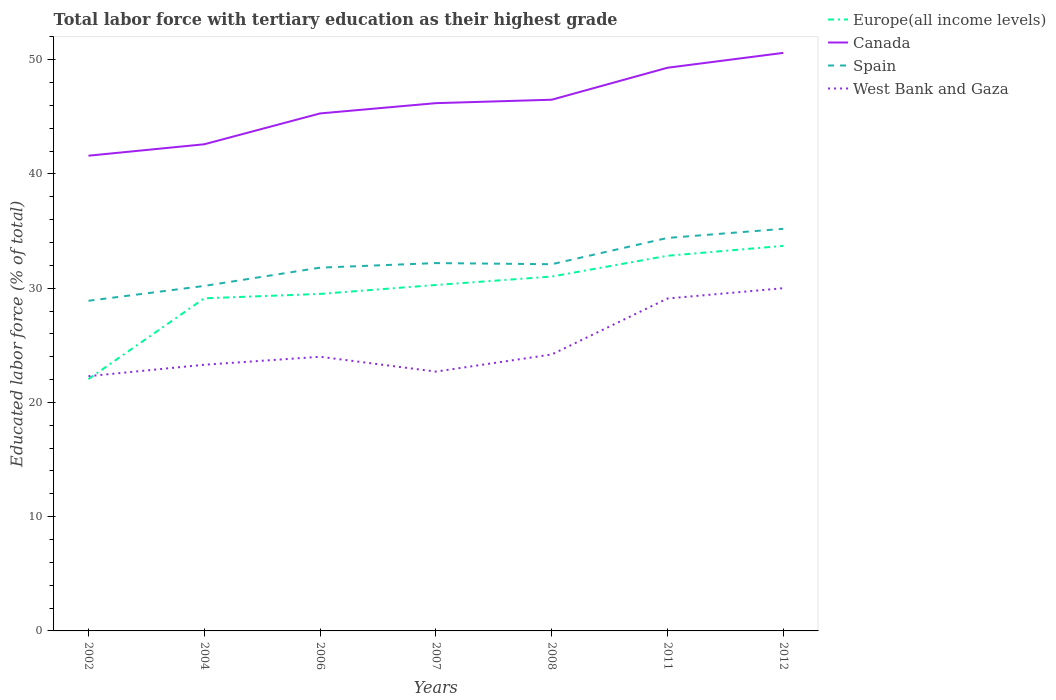Across all years, what is the maximum percentage of male labor force with tertiary education in West Bank and Gaza?
Your answer should be very brief. 22.3. In which year was the percentage of male labor force with tertiary education in West Bank and Gaza maximum?
Provide a succinct answer. 2002. What is the total percentage of male labor force with tertiary education in Spain in the graph?
Provide a short and direct response. -3.3. What is the difference between the highest and the second highest percentage of male labor force with tertiary education in Spain?
Your response must be concise. 6.3. What is the difference between the highest and the lowest percentage of male labor force with tertiary education in Europe(all income levels)?
Give a very brief answer. 4. How many lines are there?
Offer a terse response. 4. How many years are there in the graph?
Ensure brevity in your answer.  7. What is the difference between two consecutive major ticks on the Y-axis?
Offer a very short reply. 10. Does the graph contain any zero values?
Offer a terse response. No. Where does the legend appear in the graph?
Offer a terse response. Top right. How many legend labels are there?
Your answer should be very brief. 4. What is the title of the graph?
Keep it short and to the point. Total labor force with tertiary education as their highest grade. Does "Guatemala" appear as one of the legend labels in the graph?
Offer a terse response. No. What is the label or title of the X-axis?
Your response must be concise. Years. What is the label or title of the Y-axis?
Give a very brief answer. Educated labor force (% of total). What is the Educated labor force (% of total) of Europe(all income levels) in 2002?
Provide a succinct answer. 22.04. What is the Educated labor force (% of total) of Canada in 2002?
Ensure brevity in your answer.  41.6. What is the Educated labor force (% of total) in Spain in 2002?
Give a very brief answer. 28.9. What is the Educated labor force (% of total) in West Bank and Gaza in 2002?
Offer a very short reply. 22.3. What is the Educated labor force (% of total) of Europe(all income levels) in 2004?
Provide a succinct answer. 29.12. What is the Educated labor force (% of total) of Canada in 2004?
Provide a succinct answer. 42.6. What is the Educated labor force (% of total) in Spain in 2004?
Keep it short and to the point. 30.2. What is the Educated labor force (% of total) in West Bank and Gaza in 2004?
Provide a short and direct response. 23.3. What is the Educated labor force (% of total) in Europe(all income levels) in 2006?
Give a very brief answer. 29.5. What is the Educated labor force (% of total) in Canada in 2006?
Provide a succinct answer. 45.3. What is the Educated labor force (% of total) in Spain in 2006?
Offer a very short reply. 31.8. What is the Educated labor force (% of total) in Europe(all income levels) in 2007?
Your answer should be compact. 30.28. What is the Educated labor force (% of total) of Canada in 2007?
Make the answer very short. 46.2. What is the Educated labor force (% of total) in Spain in 2007?
Your answer should be compact. 32.2. What is the Educated labor force (% of total) in West Bank and Gaza in 2007?
Provide a short and direct response. 22.7. What is the Educated labor force (% of total) in Europe(all income levels) in 2008?
Provide a short and direct response. 31.02. What is the Educated labor force (% of total) of Canada in 2008?
Make the answer very short. 46.5. What is the Educated labor force (% of total) of Spain in 2008?
Offer a terse response. 32.1. What is the Educated labor force (% of total) in West Bank and Gaza in 2008?
Provide a short and direct response. 24.2. What is the Educated labor force (% of total) in Europe(all income levels) in 2011?
Offer a terse response. 32.84. What is the Educated labor force (% of total) of Canada in 2011?
Your answer should be compact. 49.3. What is the Educated labor force (% of total) in Spain in 2011?
Keep it short and to the point. 34.4. What is the Educated labor force (% of total) of West Bank and Gaza in 2011?
Give a very brief answer. 29.1. What is the Educated labor force (% of total) in Europe(all income levels) in 2012?
Your answer should be very brief. 33.71. What is the Educated labor force (% of total) in Canada in 2012?
Keep it short and to the point. 50.6. What is the Educated labor force (% of total) in Spain in 2012?
Make the answer very short. 35.2. Across all years, what is the maximum Educated labor force (% of total) of Europe(all income levels)?
Your response must be concise. 33.71. Across all years, what is the maximum Educated labor force (% of total) of Canada?
Your answer should be compact. 50.6. Across all years, what is the maximum Educated labor force (% of total) of Spain?
Give a very brief answer. 35.2. Across all years, what is the minimum Educated labor force (% of total) of Europe(all income levels)?
Provide a short and direct response. 22.04. Across all years, what is the minimum Educated labor force (% of total) of Canada?
Your answer should be very brief. 41.6. Across all years, what is the minimum Educated labor force (% of total) of Spain?
Provide a succinct answer. 28.9. Across all years, what is the minimum Educated labor force (% of total) of West Bank and Gaza?
Give a very brief answer. 22.3. What is the total Educated labor force (% of total) in Europe(all income levels) in the graph?
Make the answer very short. 208.51. What is the total Educated labor force (% of total) in Canada in the graph?
Provide a succinct answer. 322.1. What is the total Educated labor force (% of total) of Spain in the graph?
Make the answer very short. 224.8. What is the total Educated labor force (% of total) in West Bank and Gaza in the graph?
Your answer should be very brief. 175.6. What is the difference between the Educated labor force (% of total) of Europe(all income levels) in 2002 and that in 2004?
Provide a short and direct response. -7.07. What is the difference between the Educated labor force (% of total) of Canada in 2002 and that in 2004?
Make the answer very short. -1. What is the difference between the Educated labor force (% of total) in Europe(all income levels) in 2002 and that in 2006?
Your answer should be very brief. -7.46. What is the difference between the Educated labor force (% of total) in Spain in 2002 and that in 2006?
Give a very brief answer. -2.9. What is the difference between the Educated labor force (% of total) in West Bank and Gaza in 2002 and that in 2006?
Offer a terse response. -1.7. What is the difference between the Educated labor force (% of total) in Europe(all income levels) in 2002 and that in 2007?
Make the answer very short. -8.24. What is the difference between the Educated labor force (% of total) of Canada in 2002 and that in 2007?
Offer a terse response. -4.6. What is the difference between the Educated labor force (% of total) of Spain in 2002 and that in 2007?
Your answer should be very brief. -3.3. What is the difference between the Educated labor force (% of total) of Europe(all income levels) in 2002 and that in 2008?
Make the answer very short. -8.98. What is the difference between the Educated labor force (% of total) in Canada in 2002 and that in 2008?
Give a very brief answer. -4.9. What is the difference between the Educated labor force (% of total) in Europe(all income levels) in 2002 and that in 2011?
Ensure brevity in your answer.  -10.8. What is the difference between the Educated labor force (% of total) in Canada in 2002 and that in 2011?
Your answer should be very brief. -7.7. What is the difference between the Educated labor force (% of total) of West Bank and Gaza in 2002 and that in 2011?
Your answer should be compact. -6.8. What is the difference between the Educated labor force (% of total) in Europe(all income levels) in 2002 and that in 2012?
Provide a short and direct response. -11.66. What is the difference between the Educated labor force (% of total) in Spain in 2002 and that in 2012?
Your answer should be compact. -6.3. What is the difference between the Educated labor force (% of total) of Europe(all income levels) in 2004 and that in 2006?
Keep it short and to the point. -0.38. What is the difference between the Educated labor force (% of total) in Canada in 2004 and that in 2006?
Provide a short and direct response. -2.7. What is the difference between the Educated labor force (% of total) in Spain in 2004 and that in 2006?
Give a very brief answer. -1.6. What is the difference between the Educated labor force (% of total) of Europe(all income levels) in 2004 and that in 2007?
Ensure brevity in your answer.  -1.17. What is the difference between the Educated labor force (% of total) of Europe(all income levels) in 2004 and that in 2008?
Your answer should be very brief. -1.9. What is the difference between the Educated labor force (% of total) of Canada in 2004 and that in 2008?
Provide a short and direct response. -3.9. What is the difference between the Educated labor force (% of total) in West Bank and Gaza in 2004 and that in 2008?
Offer a terse response. -0.9. What is the difference between the Educated labor force (% of total) in Europe(all income levels) in 2004 and that in 2011?
Make the answer very short. -3.72. What is the difference between the Educated labor force (% of total) in West Bank and Gaza in 2004 and that in 2011?
Give a very brief answer. -5.8. What is the difference between the Educated labor force (% of total) of Europe(all income levels) in 2004 and that in 2012?
Your answer should be very brief. -4.59. What is the difference between the Educated labor force (% of total) of Canada in 2004 and that in 2012?
Provide a succinct answer. -8. What is the difference between the Educated labor force (% of total) of Europe(all income levels) in 2006 and that in 2007?
Offer a very short reply. -0.78. What is the difference between the Educated labor force (% of total) in Spain in 2006 and that in 2007?
Provide a succinct answer. -0.4. What is the difference between the Educated labor force (% of total) in West Bank and Gaza in 2006 and that in 2007?
Your answer should be compact. 1.3. What is the difference between the Educated labor force (% of total) of Europe(all income levels) in 2006 and that in 2008?
Provide a succinct answer. -1.52. What is the difference between the Educated labor force (% of total) in Europe(all income levels) in 2006 and that in 2011?
Your response must be concise. -3.34. What is the difference between the Educated labor force (% of total) in Canada in 2006 and that in 2011?
Offer a very short reply. -4. What is the difference between the Educated labor force (% of total) in Spain in 2006 and that in 2011?
Provide a succinct answer. -2.6. What is the difference between the Educated labor force (% of total) in Europe(all income levels) in 2006 and that in 2012?
Your response must be concise. -4.21. What is the difference between the Educated labor force (% of total) of Canada in 2006 and that in 2012?
Your answer should be compact. -5.3. What is the difference between the Educated labor force (% of total) in West Bank and Gaza in 2006 and that in 2012?
Give a very brief answer. -6. What is the difference between the Educated labor force (% of total) of Europe(all income levels) in 2007 and that in 2008?
Offer a terse response. -0.74. What is the difference between the Educated labor force (% of total) in Spain in 2007 and that in 2008?
Give a very brief answer. 0.1. What is the difference between the Educated labor force (% of total) of West Bank and Gaza in 2007 and that in 2008?
Provide a short and direct response. -1.5. What is the difference between the Educated labor force (% of total) of Europe(all income levels) in 2007 and that in 2011?
Give a very brief answer. -2.56. What is the difference between the Educated labor force (% of total) of Canada in 2007 and that in 2011?
Your response must be concise. -3.1. What is the difference between the Educated labor force (% of total) of Spain in 2007 and that in 2011?
Your response must be concise. -2.2. What is the difference between the Educated labor force (% of total) of Europe(all income levels) in 2007 and that in 2012?
Your response must be concise. -3.42. What is the difference between the Educated labor force (% of total) of Spain in 2007 and that in 2012?
Your answer should be very brief. -3. What is the difference between the Educated labor force (% of total) of Europe(all income levels) in 2008 and that in 2011?
Offer a very short reply. -1.82. What is the difference between the Educated labor force (% of total) of Spain in 2008 and that in 2011?
Ensure brevity in your answer.  -2.3. What is the difference between the Educated labor force (% of total) of West Bank and Gaza in 2008 and that in 2011?
Your response must be concise. -4.9. What is the difference between the Educated labor force (% of total) in Europe(all income levels) in 2008 and that in 2012?
Ensure brevity in your answer.  -2.69. What is the difference between the Educated labor force (% of total) in Canada in 2008 and that in 2012?
Keep it short and to the point. -4.1. What is the difference between the Educated labor force (% of total) of West Bank and Gaza in 2008 and that in 2012?
Ensure brevity in your answer.  -5.8. What is the difference between the Educated labor force (% of total) of Europe(all income levels) in 2011 and that in 2012?
Your answer should be compact. -0.87. What is the difference between the Educated labor force (% of total) of Spain in 2011 and that in 2012?
Ensure brevity in your answer.  -0.8. What is the difference between the Educated labor force (% of total) in West Bank and Gaza in 2011 and that in 2012?
Ensure brevity in your answer.  -0.9. What is the difference between the Educated labor force (% of total) of Europe(all income levels) in 2002 and the Educated labor force (% of total) of Canada in 2004?
Provide a succinct answer. -20.56. What is the difference between the Educated labor force (% of total) of Europe(all income levels) in 2002 and the Educated labor force (% of total) of Spain in 2004?
Offer a very short reply. -8.16. What is the difference between the Educated labor force (% of total) in Europe(all income levels) in 2002 and the Educated labor force (% of total) in West Bank and Gaza in 2004?
Provide a short and direct response. -1.26. What is the difference between the Educated labor force (% of total) of Canada in 2002 and the Educated labor force (% of total) of Spain in 2004?
Ensure brevity in your answer.  11.4. What is the difference between the Educated labor force (% of total) of Canada in 2002 and the Educated labor force (% of total) of West Bank and Gaza in 2004?
Your answer should be compact. 18.3. What is the difference between the Educated labor force (% of total) of Spain in 2002 and the Educated labor force (% of total) of West Bank and Gaza in 2004?
Offer a very short reply. 5.6. What is the difference between the Educated labor force (% of total) in Europe(all income levels) in 2002 and the Educated labor force (% of total) in Canada in 2006?
Give a very brief answer. -23.26. What is the difference between the Educated labor force (% of total) in Europe(all income levels) in 2002 and the Educated labor force (% of total) in Spain in 2006?
Ensure brevity in your answer.  -9.76. What is the difference between the Educated labor force (% of total) of Europe(all income levels) in 2002 and the Educated labor force (% of total) of West Bank and Gaza in 2006?
Provide a succinct answer. -1.96. What is the difference between the Educated labor force (% of total) of Canada in 2002 and the Educated labor force (% of total) of Spain in 2006?
Provide a short and direct response. 9.8. What is the difference between the Educated labor force (% of total) of Europe(all income levels) in 2002 and the Educated labor force (% of total) of Canada in 2007?
Provide a short and direct response. -24.16. What is the difference between the Educated labor force (% of total) in Europe(all income levels) in 2002 and the Educated labor force (% of total) in Spain in 2007?
Offer a very short reply. -10.16. What is the difference between the Educated labor force (% of total) of Europe(all income levels) in 2002 and the Educated labor force (% of total) of West Bank and Gaza in 2007?
Provide a succinct answer. -0.66. What is the difference between the Educated labor force (% of total) in Canada in 2002 and the Educated labor force (% of total) in West Bank and Gaza in 2007?
Offer a very short reply. 18.9. What is the difference between the Educated labor force (% of total) in Spain in 2002 and the Educated labor force (% of total) in West Bank and Gaza in 2007?
Provide a short and direct response. 6.2. What is the difference between the Educated labor force (% of total) of Europe(all income levels) in 2002 and the Educated labor force (% of total) of Canada in 2008?
Provide a short and direct response. -24.46. What is the difference between the Educated labor force (% of total) in Europe(all income levels) in 2002 and the Educated labor force (% of total) in Spain in 2008?
Keep it short and to the point. -10.06. What is the difference between the Educated labor force (% of total) of Europe(all income levels) in 2002 and the Educated labor force (% of total) of West Bank and Gaza in 2008?
Your answer should be compact. -2.16. What is the difference between the Educated labor force (% of total) of Canada in 2002 and the Educated labor force (% of total) of Spain in 2008?
Your answer should be very brief. 9.5. What is the difference between the Educated labor force (% of total) in Europe(all income levels) in 2002 and the Educated labor force (% of total) in Canada in 2011?
Keep it short and to the point. -27.26. What is the difference between the Educated labor force (% of total) in Europe(all income levels) in 2002 and the Educated labor force (% of total) in Spain in 2011?
Your answer should be compact. -12.36. What is the difference between the Educated labor force (% of total) in Europe(all income levels) in 2002 and the Educated labor force (% of total) in West Bank and Gaza in 2011?
Provide a short and direct response. -7.06. What is the difference between the Educated labor force (% of total) of Canada in 2002 and the Educated labor force (% of total) of Spain in 2011?
Provide a short and direct response. 7.2. What is the difference between the Educated labor force (% of total) in Canada in 2002 and the Educated labor force (% of total) in West Bank and Gaza in 2011?
Offer a very short reply. 12.5. What is the difference between the Educated labor force (% of total) of Spain in 2002 and the Educated labor force (% of total) of West Bank and Gaza in 2011?
Offer a terse response. -0.2. What is the difference between the Educated labor force (% of total) of Europe(all income levels) in 2002 and the Educated labor force (% of total) of Canada in 2012?
Give a very brief answer. -28.56. What is the difference between the Educated labor force (% of total) of Europe(all income levels) in 2002 and the Educated labor force (% of total) of Spain in 2012?
Give a very brief answer. -13.16. What is the difference between the Educated labor force (% of total) of Europe(all income levels) in 2002 and the Educated labor force (% of total) of West Bank and Gaza in 2012?
Give a very brief answer. -7.96. What is the difference between the Educated labor force (% of total) in Canada in 2002 and the Educated labor force (% of total) in West Bank and Gaza in 2012?
Give a very brief answer. 11.6. What is the difference between the Educated labor force (% of total) in Spain in 2002 and the Educated labor force (% of total) in West Bank and Gaza in 2012?
Give a very brief answer. -1.1. What is the difference between the Educated labor force (% of total) of Europe(all income levels) in 2004 and the Educated labor force (% of total) of Canada in 2006?
Your answer should be compact. -16.18. What is the difference between the Educated labor force (% of total) in Europe(all income levels) in 2004 and the Educated labor force (% of total) in Spain in 2006?
Your answer should be compact. -2.68. What is the difference between the Educated labor force (% of total) of Europe(all income levels) in 2004 and the Educated labor force (% of total) of West Bank and Gaza in 2006?
Your answer should be very brief. 5.12. What is the difference between the Educated labor force (% of total) of Canada in 2004 and the Educated labor force (% of total) of Spain in 2006?
Your response must be concise. 10.8. What is the difference between the Educated labor force (% of total) in Canada in 2004 and the Educated labor force (% of total) in West Bank and Gaza in 2006?
Provide a succinct answer. 18.6. What is the difference between the Educated labor force (% of total) in Europe(all income levels) in 2004 and the Educated labor force (% of total) in Canada in 2007?
Ensure brevity in your answer.  -17.08. What is the difference between the Educated labor force (% of total) of Europe(all income levels) in 2004 and the Educated labor force (% of total) of Spain in 2007?
Make the answer very short. -3.08. What is the difference between the Educated labor force (% of total) of Europe(all income levels) in 2004 and the Educated labor force (% of total) of West Bank and Gaza in 2007?
Keep it short and to the point. 6.42. What is the difference between the Educated labor force (% of total) of Canada in 2004 and the Educated labor force (% of total) of Spain in 2007?
Provide a short and direct response. 10.4. What is the difference between the Educated labor force (% of total) in Spain in 2004 and the Educated labor force (% of total) in West Bank and Gaza in 2007?
Your response must be concise. 7.5. What is the difference between the Educated labor force (% of total) in Europe(all income levels) in 2004 and the Educated labor force (% of total) in Canada in 2008?
Offer a terse response. -17.38. What is the difference between the Educated labor force (% of total) in Europe(all income levels) in 2004 and the Educated labor force (% of total) in Spain in 2008?
Keep it short and to the point. -2.98. What is the difference between the Educated labor force (% of total) in Europe(all income levels) in 2004 and the Educated labor force (% of total) in West Bank and Gaza in 2008?
Your response must be concise. 4.92. What is the difference between the Educated labor force (% of total) of Canada in 2004 and the Educated labor force (% of total) of Spain in 2008?
Your response must be concise. 10.5. What is the difference between the Educated labor force (% of total) in Canada in 2004 and the Educated labor force (% of total) in West Bank and Gaza in 2008?
Your answer should be compact. 18.4. What is the difference between the Educated labor force (% of total) in Spain in 2004 and the Educated labor force (% of total) in West Bank and Gaza in 2008?
Provide a short and direct response. 6. What is the difference between the Educated labor force (% of total) of Europe(all income levels) in 2004 and the Educated labor force (% of total) of Canada in 2011?
Ensure brevity in your answer.  -20.18. What is the difference between the Educated labor force (% of total) of Europe(all income levels) in 2004 and the Educated labor force (% of total) of Spain in 2011?
Your answer should be compact. -5.28. What is the difference between the Educated labor force (% of total) in Europe(all income levels) in 2004 and the Educated labor force (% of total) in West Bank and Gaza in 2011?
Make the answer very short. 0.02. What is the difference between the Educated labor force (% of total) in Canada in 2004 and the Educated labor force (% of total) in West Bank and Gaza in 2011?
Provide a short and direct response. 13.5. What is the difference between the Educated labor force (% of total) of Europe(all income levels) in 2004 and the Educated labor force (% of total) of Canada in 2012?
Provide a short and direct response. -21.48. What is the difference between the Educated labor force (% of total) in Europe(all income levels) in 2004 and the Educated labor force (% of total) in Spain in 2012?
Make the answer very short. -6.08. What is the difference between the Educated labor force (% of total) in Europe(all income levels) in 2004 and the Educated labor force (% of total) in West Bank and Gaza in 2012?
Ensure brevity in your answer.  -0.88. What is the difference between the Educated labor force (% of total) of Canada in 2004 and the Educated labor force (% of total) of West Bank and Gaza in 2012?
Offer a terse response. 12.6. What is the difference between the Educated labor force (% of total) of Europe(all income levels) in 2006 and the Educated labor force (% of total) of Canada in 2007?
Offer a terse response. -16.7. What is the difference between the Educated labor force (% of total) in Europe(all income levels) in 2006 and the Educated labor force (% of total) in Spain in 2007?
Provide a succinct answer. -2.7. What is the difference between the Educated labor force (% of total) in Europe(all income levels) in 2006 and the Educated labor force (% of total) in West Bank and Gaza in 2007?
Your answer should be compact. 6.8. What is the difference between the Educated labor force (% of total) in Canada in 2006 and the Educated labor force (% of total) in Spain in 2007?
Offer a terse response. 13.1. What is the difference between the Educated labor force (% of total) in Canada in 2006 and the Educated labor force (% of total) in West Bank and Gaza in 2007?
Give a very brief answer. 22.6. What is the difference between the Educated labor force (% of total) in Spain in 2006 and the Educated labor force (% of total) in West Bank and Gaza in 2007?
Your response must be concise. 9.1. What is the difference between the Educated labor force (% of total) in Europe(all income levels) in 2006 and the Educated labor force (% of total) in Canada in 2008?
Your answer should be very brief. -17. What is the difference between the Educated labor force (% of total) of Europe(all income levels) in 2006 and the Educated labor force (% of total) of Spain in 2008?
Offer a very short reply. -2.6. What is the difference between the Educated labor force (% of total) of Europe(all income levels) in 2006 and the Educated labor force (% of total) of West Bank and Gaza in 2008?
Make the answer very short. 5.3. What is the difference between the Educated labor force (% of total) in Canada in 2006 and the Educated labor force (% of total) in Spain in 2008?
Your answer should be very brief. 13.2. What is the difference between the Educated labor force (% of total) in Canada in 2006 and the Educated labor force (% of total) in West Bank and Gaza in 2008?
Keep it short and to the point. 21.1. What is the difference between the Educated labor force (% of total) in Spain in 2006 and the Educated labor force (% of total) in West Bank and Gaza in 2008?
Provide a short and direct response. 7.6. What is the difference between the Educated labor force (% of total) of Europe(all income levels) in 2006 and the Educated labor force (% of total) of Canada in 2011?
Your answer should be very brief. -19.8. What is the difference between the Educated labor force (% of total) of Europe(all income levels) in 2006 and the Educated labor force (% of total) of Spain in 2011?
Offer a very short reply. -4.9. What is the difference between the Educated labor force (% of total) of Europe(all income levels) in 2006 and the Educated labor force (% of total) of West Bank and Gaza in 2011?
Your answer should be very brief. 0.4. What is the difference between the Educated labor force (% of total) of Canada in 2006 and the Educated labor force (% of total) of Spain in 2011?
Make the answer very short. 10.9. What is the difference between the Educated labor force (% of total) of Canada in 2006 and the Educated labor force (% of total) of West Bank and Gaza in 2011?
Give a very brief answer. 16.2. What is the difference between the Educated labor force (% of total) of Europe(all income levels) in 2006 and the Educated labor force (% of total) of Canada in 2012?
Provide a short and direct response. -21.1. What is the difference between the Educated labor force (% of total) in Europe(all income levels) in 2006 and the Educated labor force (% of total) in Spain in 2012?
Ensure brevity in your answer.  -5.7. What is the difference between the Educated labor force (% of total) of Europe(all income levels) in 2006 and the Educated labor force (% of total) of West Bank and Gaza in 2012?
Provide a succinct answer. -0.5. What is the difference between the Educated labor force (% of total) in Canada in 2006 and the Educated labor force (% of total) in West Bank and Gaza in 2012?
Offer a terse response. 15.3. What is the difference between the Educated labor force (% of total) of Spain in 2006 and the Educated labor force (% of total) of West Bank and Gaza in 2012?
Your response must be concise. 1.8. What is the difference between the Educated labor force (% of total) in Europe(all income levels) in 2007 and the Educated labor force (% of total) in Canada in 2008?
Provide a succinct answer. -16.22. What is the difference between the Educated labor force (% of total) in Europe(all income levels) in 2007 and the Educated labor force (% of total) in Spain in 2008?
Provide a succinct answer. -1.82. What is the difference between the Educated labor force (% of total) in Europe(all income levels) in 2007 and the Educated labor force (% of total) in West Bank and Gaza in 2008?
Keep it short and to the point. 6.08. What is the difference between the Educated labor force (% of total) of Europe(all income levels) in 2007 and the Educated labor force (% of total) of Canada in 2011?
Provide a succinct answer. -19.02. What is the difference between the Educated labor force (% of total) of Europe(all income levels) in 2007 and the Educated labor force (% of total) of Spain in 2011?
Offer a terse response. -4.12. What is the difference between the Educated labor force (% of total) of Europe(all income levels) in 2007 and the Educated labor force (% of total) of West Bank and Gaza in 2011?
Your response must be concise. 1.18. What is the difference between the Educated labor force (% of total) in Canada in 2007 and the Educated labor force (% of total) in Spain in 2011?
Provide a succinct answer. 11.8. What is the difference between the Educated labor force (% of total) of Spain in 2007 and the Educated labor force (% of total) of West Bank and Gaza in 2011?
Provide a succinct answer. 3.1. What is the difference between the Educated labor force (% of total) in Europe(all income levels) in 2007 and the Educated labor force (% of total) in Canada in 2012?
Offer a very short reply. -20.32. What is the difference between the Educated labor force (% of total) of Europe(all income levels) in 2007 and the Educated labor force (% of total) of Spain in 2012?
Your response must be concise. -4.92. What is the difference between the Educated labor force (% of total) of Europe(all income levels) in 2007 and the Educated labor force (% of total) of West Bank and Gaza in 2012?
Your answer should be compact. 0.28. What is the difference between the Educated labor force (% of total) of Canada in 2007 and the Educated labor force (% of total) of West Bank and Gaza in 2012?
Your answer should be very brief. 16.2. What is the difference between the Educated labor force (% of total) in Europe(all income levels) in 2008 and the Educated labor force (% of total) in Canada in 2011?
Keep it short and to the point. -18.28. What is the difference between the Educated labor force (% of total) in Europe(all income levels) in 2008 and the Educated labor force (% of total) in Spain in 2011?
Your answer should be compact. -3.38. What is the difference between the Educated labor force (% of total) of Europe(all income levels) in 2008 and the Educated labor force (% of total) of West Bank and Gaza in 2011?
Your answer should be very brief. 1.92. What is the difference between the Educated labor force (% of total) in Canada in 2008 and the Educated labor force (% of total) in West Bank and Gaza in 2011?
Your answer should be compact. 17.4. What is the difference between the Educated labor force (% of total) in Europe(all income levels) in 2008 and the Educated labor force (% of total) in Canada in 2012?
Your answer should be compact. -19.58. What is the difference between the Educated labor force (% of total) in Europe(all income levels) in 2008 and the Educated labor force (% of total) in Spain in 2012?
Provide a short and direct response. -4.18. What is the difference between the Educated labor force (% of total) in Europe(all income levels) in 2008 and the Educated labor force (% of total) in West Bank and Gaza in 2012?
Provide a succinct answer. 1.02. What is the difference between the Educated labor force (% of total) of Canada in 2008 and the Educated labor force (% of total) of West Bank and Gaza in 2012?
Offer a terse response. 16.5. What is the difference between the Educated labor force (% of total) of Spain in 2008 and the Educated labor force (% of total) of West Bank and Gaza in 2012?
Offer a very short reply. 2.1. What is the difference between the Educated labor force (% of total) of Europe(all income levels) in 2011 and the Educated labor force (% of total) of Canada in 2012?
Give a very brief answer. -17.76. What is the difference between the Educated labor force (% of total) of Europe(all income levels) in 2011 and the Educated labor force (% of total) of Spain in 2012?
Your answer should be very brief. -2.36. What is the difference between the Educated labor force (% of total) of Europe(all income levels) in 2011 and the Educated labor force (% of total) of West Bank and Gaza in 2012?
Make the answer very short. 2.84. What is the difference between the Educated labor force (% of total) in Canada in 2011 and the Educated labor force (% of total) in Spain in 2012?
Ensure brevity in your answer.  14.1. What is the difference between the Educated labor force (% of total) in Canada in 2011 and the Educated labor force (% of total) in West Bank and Gaza in 2012?
Offer a very short reply. 19.3. What is the average Educated labor force (% of total) in Europe(all income levels) per year?
Keep it short and to the point. 29.79. What is the average Educated labor force (% of total) of Canada per year?
Offer a very short reply. 46.01. What is the average Educated labor force (% of total) of Spain per year?
Provide a succinct answer. 32.11. What is the average Educated labor force (% of total) in West Bank and Gaza per year?
Offer a terse response. 25.09. In the year 2002, what is the difference between the Educated labor force (% of total) in Europe(all income levels) and Educated labor force (% of total) in Canada?
Make the answer very short. -19.56. In the year 2002, what is the difference between the Educated labor force (% of total) of Europe(all income levels) and Educated labor force (% of total) of Spain?
Provide a succinct answer. -6.86. In the year 2002, what is the difference between the Educated labor force (% of total) in Europe(all income levels) and Educated labor force (% of total) in West Bank and Gaza?
Give a very brief answer. -0.26. In the year 2002, what is the difference between the Educated labor force (% of total) of Canada and Educated labor force (% of total) of Spain?
Your response must be concise. 12.7. In the year 2002, what is the difference between the Educated labor force (% of total) in Canada and Educated labor force (% of total) in West Bank and Gaza?
Ensure brevity in your answer.  19.3. In the year 2002, what is the difference between the Educated labor force (% of total) in Spain and Educated labor force (% of total) in West Bank and Gaza?
Your response must be concise. 6.6. In the year 2004, what is the difference between the Educated labor force (% of total) of Europe(all income levels) and Educated labor force (% of total) of Canada?
Provide a succinct answer. -13.48. In the year 2004, what is the difference between the Educated labor force (% of total) in Europe(all income levels) and Educated labor force (% of total) in Spain?
Provide a succinct answer. -1.08. In the year 2004, what is the difference between the Educated labor force (% of total) in Europe(all income levels) and Educated labor force (% of total) in West Bank and Gaza?
Offer a terse response. 5.82. In the year 2004, what is the difference between the Educated labor force (% of total) in Canada and Educated labor force (% of total) in Spain?
Provide a short and direct response. 12.4. In the year 2004, what is the difference between the Educated labor force (% of total) in Canada and Educated labor force (% of total) in West Bank and Gaza?
Ensure brevity in your answer.  19.3. In the year 2004, what is the difference between the Educated labor force (% of total) of Spain and Educated labor force (% of total) of West Bank and Gaza?
Ensure brevity in your answer.  6.9. In the year 2006, what is the difference between the Educated labor force (% of total) in Europe(all income levels) and Educated labor force (% of total) in Canada?
Your answer should be compact. -15.8. In the year 2006, what is the difference between the Educated labor force (% of total) of Europe(all income levels) and Educated labor force (% of total) of Spain?
Provide a short and direct response. -2.3. In the year 2006, what is the difference between the Educated labor force (% of total) in Europe(all income levels) and Educated labor force (% of total) in West Bank and Gaza?
Offer a very short reply. 5.5. In the year 2006, what is the difference between the Educated labor force (% of total) in Canada and Educated labor force (% of total) in West Bank and Gaza?
Your response must be concise. 21.3. In the year 2007, what is the difference between the Educated labor force (% of total) in Europe(all income levels) and Educated labor force (% of total) in Canada?
Offer a terse response. -15.92. In the year 2007, what is the difference between the Educated labor force (% of total) of Europe(all income levels) and Educated labor force (% of total) of Spain?
Provide a short and direct response. -1.92. In the year 2007, what is the difference between the Educated labor force (% of total) in Europe(all income levels) and Educated labor force (% of total) in West Bank and Gaza?
Your answer should be compact. 7.58. In the year 2007, what is the difference between the Educated labor force (% of total) of Canada and Educated labor force (% of total) of West Bank and Gaza?
Your answer should be compact. 23.5. In the year 2007, what is the difference between the Educated labor force (% of total) of Spain and Educated labor force (% of total) of West Bank and Gaza?
Your answer should be compact. 9.5. In the year 2008, what is the difference between the Educated labor force (% of total) in Europe(all income levels) and Educated labor force (% of total) in Canada?
Provide a succinct answer. -15.48. In the year 2008, what is the difference between the Educated labor force (% of total) in Europe(all income levels) and Educated labor force (% of total) in Spain?
Offer a very short reply. -1.08. In the year 2008, what is the difference between the Educated labor force (% of total) in Europe(all income levels) and Educated labor force (% of total) in West Bank and Gaza?
Your response must be concise. 6.82. In the year 2008, what is the difference between the Educated labor force (% of total) of Canada and Educated labor force (% of total) of West Bank and Gaza?
Your response must be concise. 22.3. In the year 2008, what is the difference between the Educated labor force (% of total) of Spain and Educated labor force (% of total) of West Bank and Gaza?
Provide a short and direct response. 7.9. In the year 2011, what is the difference between the Educated labor force (% of total) in Europe(all income levels) and Educated labor force (% of total) in Canada?
Make the answer very short. -16.46. In the year 2011, what is the difference between the Educated labor force (% of total) in Europe(all income levels) and Educated labor force (% of total) in Spain?
Offer a very short reply. -1.56. In the year 2011, what is the difference between the Educated labor force (% of total) of Europe(all income levels) and Educated labor force (% of total) of West Bank and Gaza?
Provide a short and direct response. 3.74. In the year 2011, what is the difference between the Educated labor force (% of total) of Canada and Educated labor force (% of total) of West Bank and Gaza?
Provide a succinct answer. 20.2. In the year 2011, what is the difference between the Educated labor force (% of total) of Spain and Educated labor force (% of total) of West Bank and Gaza?
Give a very brief answer. 5.3. In the year 2012, what is the difference between the Educated labor force (% of total) of Europe(all income levels) and Educated labor force (% of total) of Canada?
Provide a succinct answer. -16.89. In the year 2012, what is the difference between the Educated labor force (% of total) in Europe(all income levels) and Educated labor force (% of total) in Spain?
Keep it short and to the point. -1.49. In the year 2012, what is the difference between the Educated labor force (% of total) of Europe(all income levels) and Educated labor force (% of total) of West Bank and Gaza?
Keep it short and to the point. 3.71. In the year 2012, what is the difference between the Educated labor force (% of total) in Canada and Educated labor force (% of total) in Spain?
Your answer should be very brief. 15.4. In the year 2012, what is the difference between the Educated labor force (% of total) in Canada and Educated labor force (% of total) in West Bank and Gaza?
Ensure brevity in your answer.  20.6. What is the ratio of the Educated labor force (% of total) of Europe(all income levels) in 2002 to that in 2004?
Give a very brief answer. 0.76. What is the ratio of the Educated labor force (% of total) of Canada in 2002 to that in 2004?
Make the answer very short. 0.98. What is the ratio of the Educated labor force (% of total) of Spain in 2002 to that in 2004?
Your response must be concise. 0.96. What is the ratio of the Educated labor force (% of total) of West Bank and Gaza in 2002 to that in 2004?
Provide a short and direct response. 0.96. What is the ratio of the Educated labor force (% of total) of Europe(all income levels) in 2002 to that in 2006?
Offer a very short reply. 0.75. What is the ratio of the Educated labor force (% of total) of Canada in 2002 to that in 2006?
Keep it short and to the point. 0.92. What is the ratio of the Educated labor force (% of total) of Spain in 2002 to that in 2006?
Offer a very short reply. 0.91. What is the ratio of the Educated labor force (% of total) of West Bank and Gaza in 2002 to that in 2006?
Your response must be concise. 0.93. What is the ratio of the Educated labor force (% of total) in Europe(all income levels) in 2002 to that in 2007?
Provide a succinct answer. 0.73. What is the ratio of the Educated labor force (% of total) in Canada in 2002 to that in 2007?
Give a very brief answer. 0.9. What is the ratio of the Educated labor force (% of total) of Spain in 2002 to that in 2007?
Offer a terse response. 0.9. What is the ratio of the Educated labor force (% of total) in West Bank and Gaza in 2002 to that in 2007?
Offer a terse response. 0.98. What is the ratio of the Educated labor force (% of total) of Europe(all income levels) in 2002 to that in 2008?
Keep it short and to the point. 0.71. What is the ratio of the Educated labor force (% of total) of Canada in 2002 to that in 2008?
Your answer should be compact. 0.89. What is the ratio of the Educated labor force (% of total) of Spain in 2002 to that in 2008?
Ensure brevity in your answer.  0.9. What is the ratio of the Educated labor force (% of total) of West Bank and Gaza in 2002 to that in 2008?
Give a very brief answer. 0.92. What is the ratio of the Educated labor force (% of total) of Europe(all income levels) in 2002 to that in 2011?
Provide a short and direct response. 0.67. What is the ratio of the Educated labor force (% of total) of Canada in 2002 to that in 2011?
Your response must be concise. 0.84. What is the ratio of the Educated labor force (% of total) in Spain in 2002 to that in 2011?
Make the answer very short. 0.84. What is the ratio of the Educated labor force (% of total) in West Bank and Gaza in 2002 to that in 2011?
Ensure brevity in your answer.  0.77. What is the ratio of the Educated labor force (% of total) in Europe(all income levels) in 2002 to that in 2012?
Ensure brevity in your answer.  0.65. What is the ratio of the Educated labor force (% of total) of Canada in 2002 to that in 2012?
Make the answer very short. 0.82. What is the ratio of the Educated labor force (% of total) of Spain in 2002 to that in 2012?
Your answer should be compact. 0.82. What is the ratio of the Educated labor force (% of total) in West Bank and Gaza in 2002 to that in 2012?
Provide a short and direct response. 0.74. What is the ratio of the Educated labor force (% of total) of Europe(all income levels) in 2004 to that in 2006?
Your answer should be very brief. 0.99. What is the ratio of the Educated labor force (% of total) in Canada in 2004 to that in 2006?
Ensure brevity in your answer.  0.94. What is the ratio of the Educated labor force (% of total) in Spain in 2004 to that in 2006?
Provide a short and direct response. 0.95. What is the ratio of the Educated labor force (% of total) of West Bank and Gaza in 2004 to that in 2006?
Provide a succinct answer. 0.97. What is the ratio of the Educated labor force (% of total) of Europe(all income levels) in 2004 to that in 2007?
Keep it short and to the point. 0.96. What is the ratio of the Educated labor force (% of total) in Canada in 2004 to that in 2007?
Keep it short and to the point. 0.92. What is the ratio of the Educated labor force (% of total) in Spain in 2004 to that in 2007?
Your answer should be very brief. 0.94. What is the ratio of the Educated labor force (% of total) of West Bank and Gaza in 2004 to that in 2007?
Your answer should be very brief. 1.03. What is the ratio of the Educated labor force (% of total) in Europe(all income levels) in 2004 to that in 2008?
Offer a very short reply. 0.94. What is the ratio of the Educated labor force (% of total) in Canada in 2004 to that in 2008?
Your response must be concise. 0.92. What is the ratio of the Educated labor force (% of total) of Spain in 2004 to that in 2008?
Your answer should be very brief. 0.94. What is the ratio of the Educated labor force (% of total) of West Bank and Gaza in 2004 to that in 2008?
Give a very brief answer. 0.96. What is the ratio of the Educated labor force (% of total) of Europe(all income levels) in 2004 to that in 2011?
Your answer should be very brief. 0.89. What is the ratio of the Educated labor force (% of total) in Canada in 2004 to that in 2011?
Give a very brief answer. 0.86. What is the ratio of the Educated labor force (% of total) of Spain in 2004 to that in 2011?
Your answer should be compact. 0.88. What is the ratio of the Educated labor force (% of total) of West Bank and Gaza in 2004 to that in 2011?
Your answer should be very brief. 0.8. What is the ratio of the Educated labor force (% of total) of Europe(all income levels) in 2004 to that in 2012?
Give a very brief answer. 0.86. What is the ratio of the Educated labor force (% of total) in Canada in 2004 to that in 2012?
Your answer should be very brief. 0.84. What is the ratio of the Educated labor force (% of total) in Spain in 2004 to that in 2012?
Give a very brief answer. 0.86. What is the ratio of the Educated labor force (% of total) of West Bank and Gaza in 2004 to that in 2012?
Give a very brief answer. 0.78. What is the ratio of the Educated labor force (% of total) in Europe(all income levels) in 2006 to that in 2007?
Keep it short and to the point. 0.97. What is the ratio of the Educated labor force (% of total) of Canada in 2006 to that in 2007?
Keep it short and to the point. 0.98. What is the ratio of the Educated labor force (% of total) of Spain in 2006 to that in 2007?
Your answer should be compact. 0.99. What is the ratio of the Educated labor force (% of total) in West Bank and Gaza in 2006 to that in 2007?
Make the answer very short. 1.06. What is the ratio of the Educated labor force (% of total) in Europe(all income levels) in 2006 to that in 2008?
Your answer should be very brief. 0.95. What is the ratio of the Educated labor force (% of total) in Canada in 2006 to that in 2008?
Provide a succinct answer. 0.97. What is the ratio of the Educated labor force (% of total) of Spain in 2006 to that in 2008?
Provide a succinct answer. 0.99. What is the ratio of the Educated labor force (% of total) in West Bank and Gaza in 2006 to that in 2008?
Your answer should be very brief. 0.99. What is the ratio of the Educated labor force (% of total) in Europe(all income levels) in 2006 to that in 2011?
Offer a very short reply. 0.9. What is the ratio of the Educated labor force (% of total) of Canada in 2006 to that in 2011?
Keep it short and to the point. 0.92. What is the ratio of the Educated labor force (% of total) in Spain in 2006 to that in 2011?
Keep it short and to the point. 0.92. What is the ratio of the Educated labor force (% of total) in West Bank and Gaza in 2006 to that in 2011?
Provide a succinct answer. 0.82. What is the ratio of the Educated labor force (% of total) of Europe(all income levels) in 2006 to that in 2012?
Make the answer very short. 0.88. What is the ratio of the Educated labor force (% of total) of Canada in 2006 to that in 2012?
Make the answer very short. 0.9. What is the ratio of the Educated labor force (% of total) in Spain in 2006 to that in 2012?
Keep it short and to the point. 0.9. What is the ratio of the Educated labor force (% of total) of Europe(all income levels) in 2007 to that in 2008?
Offer a very short reply. 0.98. What is the ratio of the Educated labor force (% of total) in West Bank and Gaza in 2007 to that in 2008?
Ensure brevity in your answer.  0.94. What is the ratio of the Educated labor force (% of total) of Europe(all income levels) in 2007 to that in 2011?
Provide a succinct answer. 0.92. What is the ratio of the Educated labor force (% of total) of Canada in 2007 to that in 2011?
Your answer should be very brief. 0.94. What is the ratio of the Educated labor force (% of total) of Spain in 2007 to that in 2011?
Your answer should be compact. 0.94. What is the ratio of the Educated labor force (% of total) in West Bank and Gaza in 2007 to that in 2011?
Ensure brevity in your answer.  0.78. What is the ratio of the Educated labor force (% of total) in Europe(all income levels) in 2007 to that in 2012?
Your response must be concise. 0.9. What is the ratio of the Educated labor force (% of total) in Canada in 2007 to that in 2012?
Offer a very short reply. 0.91. What is the ratio of the Educated labor force (% of total) in Spain in 2007 to that in 2012?
Give a very brief answer. 0.91. What is the ratio of the Educated labor force (% of total) of West Bank and Gaza in 2007 to that in 2012?
Your response must be concise. 0.76. What is the ratio of the Educated labor force (% of total) in Europe(all income levels) in 2008 to that in 2011?
Offer a very short reply. 0.94. What is the ratio of the Educated labor force (% of total) in Canada in 2008 to that in 2011?
Make the answer very short. 0.94. What is the ratio of the Educated labor force (% of total) in Spain in 2008 to that in 2011?
Ensure brevity in your answer.  0.93. What is the ratio of the Educated labor force (% of total) of West Bank and Gaza in 2008 to that in 2011?
Provide a short and direct response. 0.83. What is the ratio of the Educated labor force (% of total) of Europe(all income levels) in 2008 to that in 2012?
Your answer should be very brief. 0.92. What is the ratio of the Educated labor force (% of total) in Canada in 2008 to that in 2012?
Ensure brevity in your answer.  0.92. What is the ratio of the Educated labor force (% of total) in Spain in 2008 to that in 2012?
Your answer should be compact. 0.91. What is the ratio of the Educated labor force (% of total) of West Bank and Gaza in 2008 to that in 2012?
Ensure brevity in your answer.  0.81. What is the ratio of the Educated labor force (% of total) of Europe(all income levels) in 2011 to that in 2012?
Give a very brief answer. 0.97. What is the ratio of the Educated labor force (% of total) in Canada in 2011 to that in 2012?
Keep it short and to the point. 0.97. What is the ratio of the Educated labor force (% of total) in Spain in 2011 to that in 2012?
Your response must be concise. 0.98. What is the ratio of the Educated labor force (% of total) in West Bank and Gaza in 2011 to that in 2012?
Give a very brief answer. 0.97. What is the difference between the highest and the second highest Educated labor force (% of total) of Europe(all income levels)?
Offer a terse response. 0.87. What is the difference between the highest and the lowest Educated labor force (% of total) in Europe(all income levels)?
Give a very brief answer. 11.66. What is the difference between the highest and the lowest Educated labor force (% of total) of Spain?
Offer a very short reply. 6.3. What is the difference between the highest and the lowest Educated labor force (% of total) in West Bank and Gaza?
Offer a terse response. 7.7. 